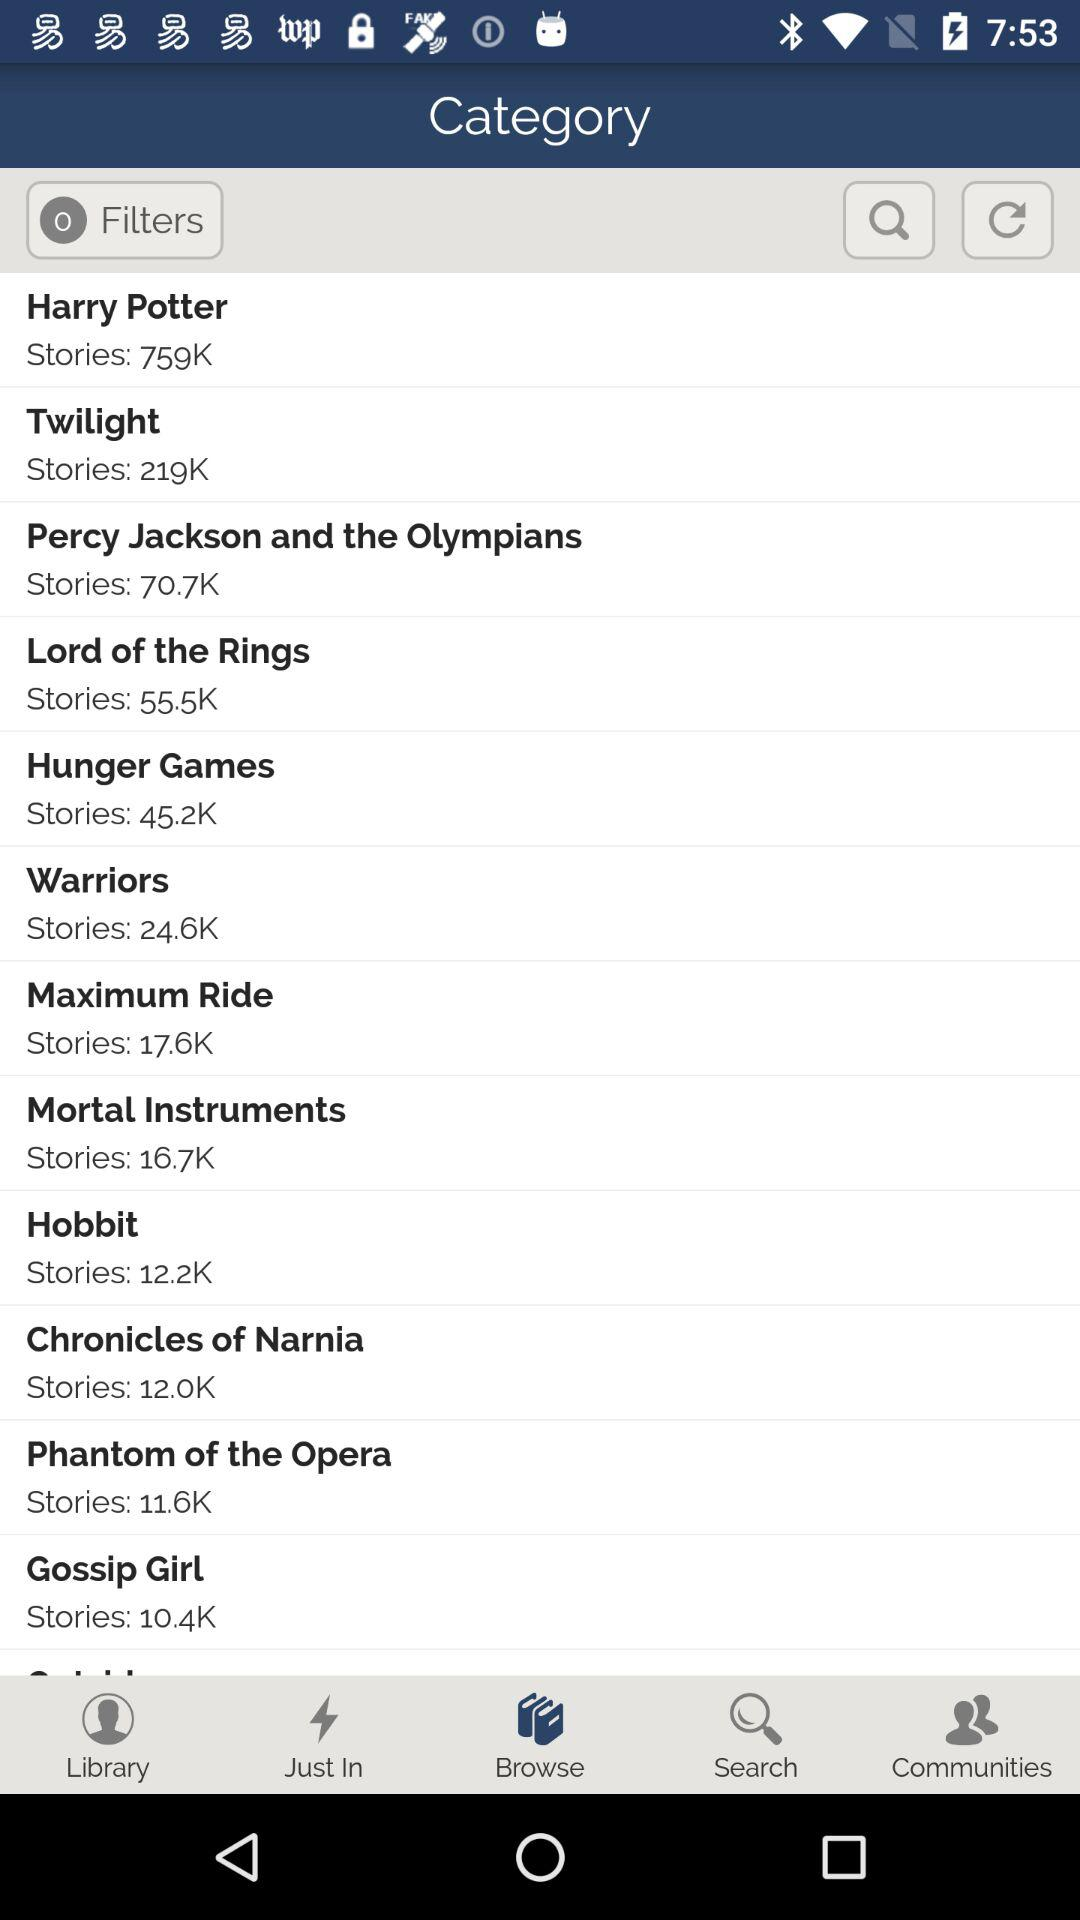Which tab is selected? The selected tab is "Browse". 